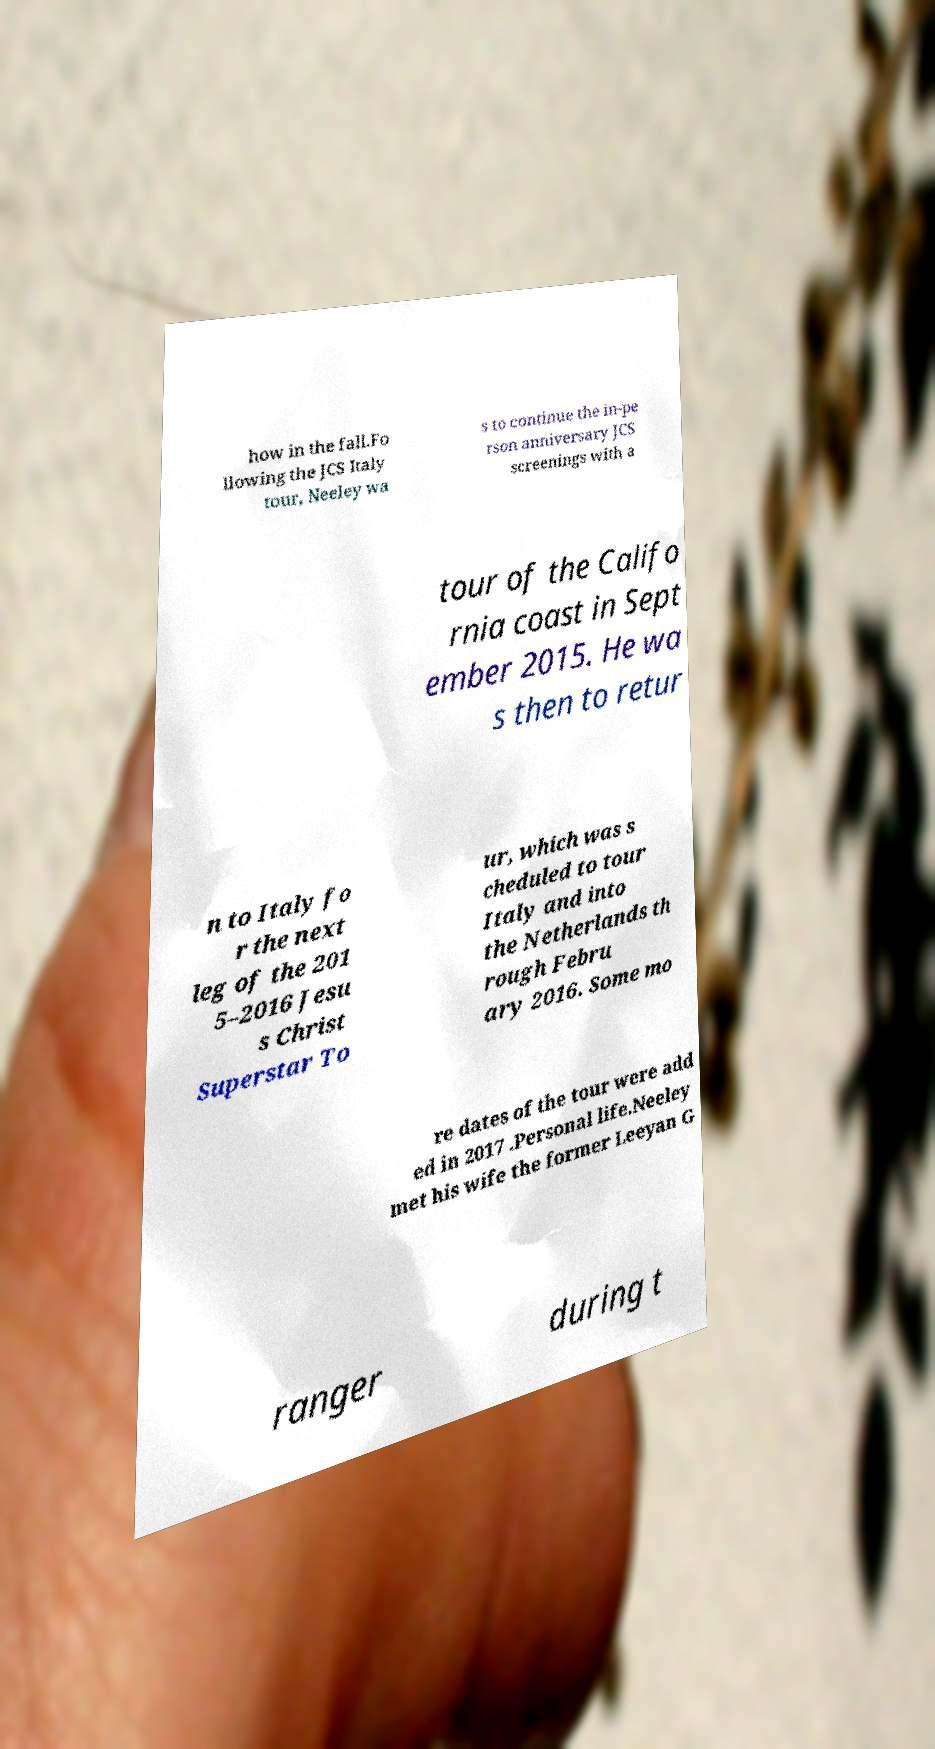Could you assist in decoding the text presented in this image and type it out clearly? how in the fall.Fo llowing the JCS Italy tour, Neeley wa s to continue the in-pe rson anniversary JCS screenings with a tour of the Califo rnia coast in Sept ember 2015. He wa s then to retur n to Italy fo r the next leg of the 201 5–2016 Jesu s Christ Superstar To ur, which was s cheduled to tour Italy and into the Netherlands th rough Febru ary 2016. Some mo re dates of the tour were add ed in 2017 .Personal life.Neeley met his wife the former Leeyan G ranger during t 